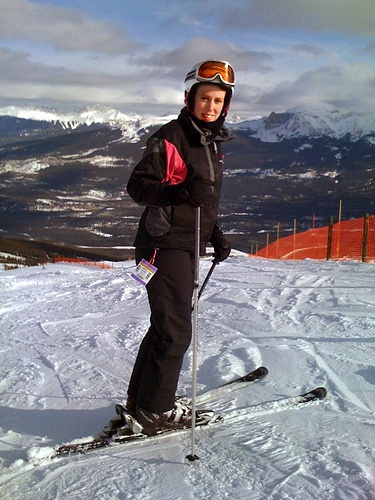Describe the objects in this image and their specific colors. I can see people in darkgray, black, gray, and maroon tones and skis in darkgray, black, lightgray, and gray tones in this image. 